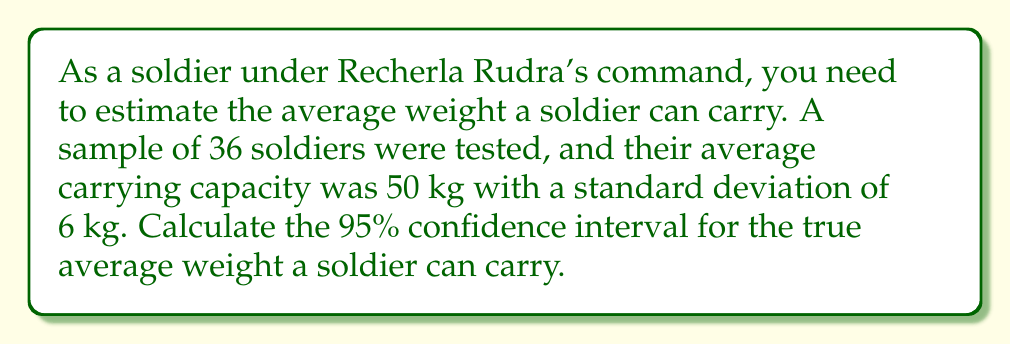Show me your answer to this math problem. To calculate the confidence interval, we'll follow these steps:

1. Identify the given information:
   - Sample size (n) = 36
   - Sample mean ($\bar{x}$) = 50 kg
   - Sample standard deviation (s) = 6 kg
   - Confidence level = 95%

2. Find the critical value (t-score) for a 95% confidence level with 35 degrees of freedom:
   $t_{0.025, 35} = 2.030$ (from t-distribution table)

3. Calculate the standard error of the mean:
   $SE = \frac{s}{\sqrt{n}} = \frac{6}{\sqrt{36}} = \frac{6}{6} = 1$

4. Calculate the margin of error:
   $ME = t_{0.025, 35} \times SE = 2.030 \times 1 = 2.030$

5. Calculate the confidence interval:
   Lower bound: $\bar{x} - ME = 50 - 2.030 = 47.97$ kg
   Upper bound: $\bar{x} + ME = 50 + 2.030 = 52.03$ kg

Therefore, the 95% confidence interval for the true average weight a soldier can carry is (47.97 kg, 52.03 kg).
Answer: (47.97 kg, 52.03 kg) 